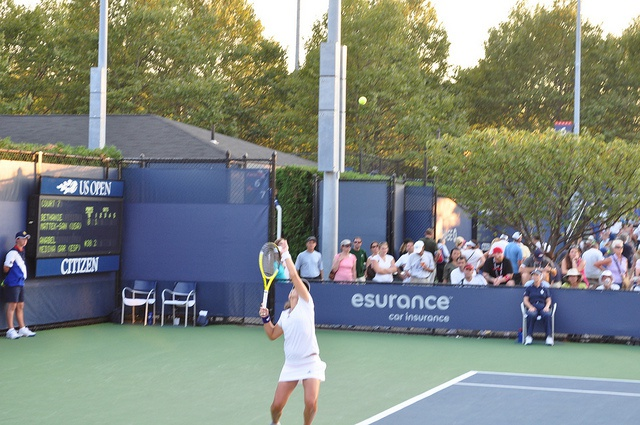Describe the objects in this image and their specific colors. I can see people in olive, lavender, gray, darkgray, and lightpink tones, people in olive, lavender, gray, darkgray, and black tones, people in olive, black, lavender, navy, and brown tones, people in olive, navy, lavender, darkgray, and gray tones, and chair in olive, lavender, navy, gray, and black tones in this image. 